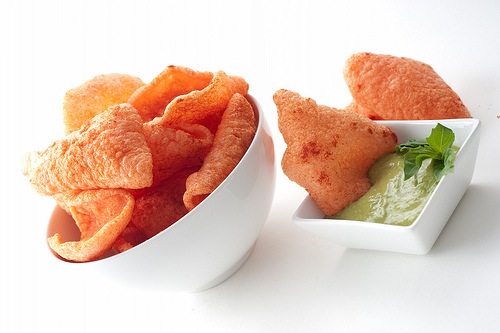<image>
Is there a chip in the bowl? No. The chip is not contained within the bowl. These objects have a different spatial relationship. Is there a pork rinds on the bowl? Yes. Looking at the image, I can see the pork rinds is positioned on top of the bowl, with the bowl providing support. 